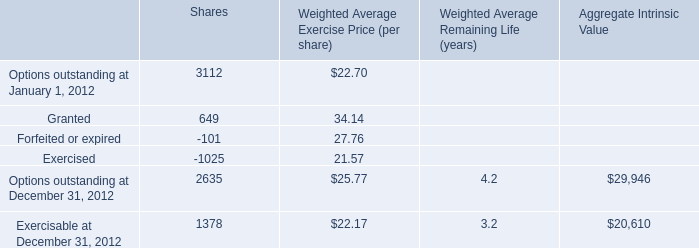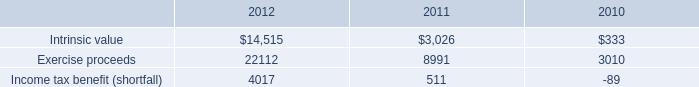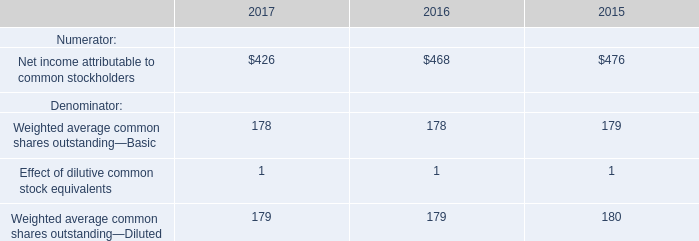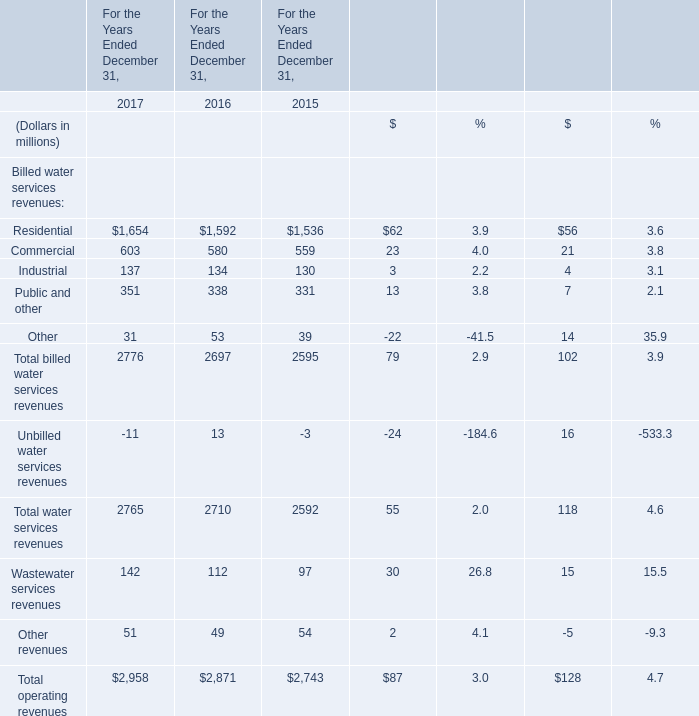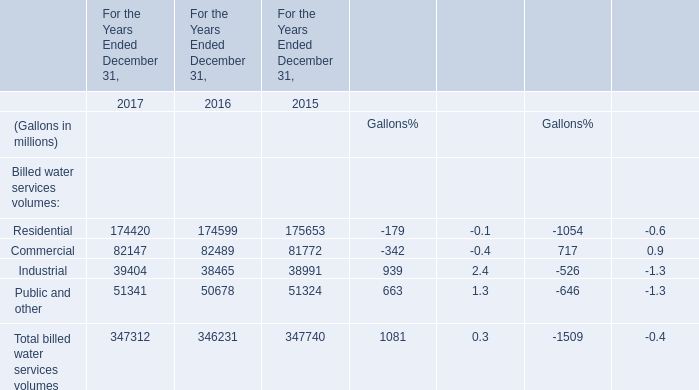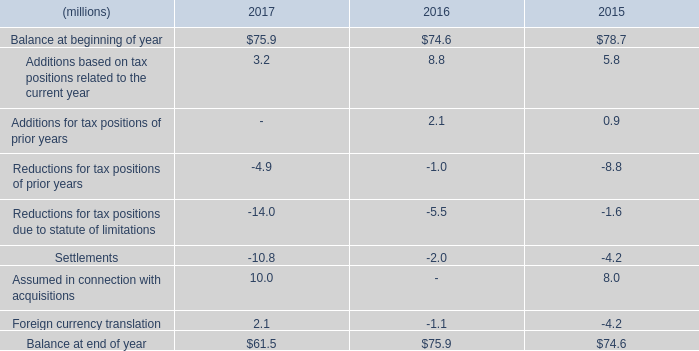What will Commercial be like in 2018 if it continues to grow at the same rate as it did in 2017? (in million) 
Computations: (603 * (1 + ((603 - 580) / 580)))
Answer: 626.91207. 